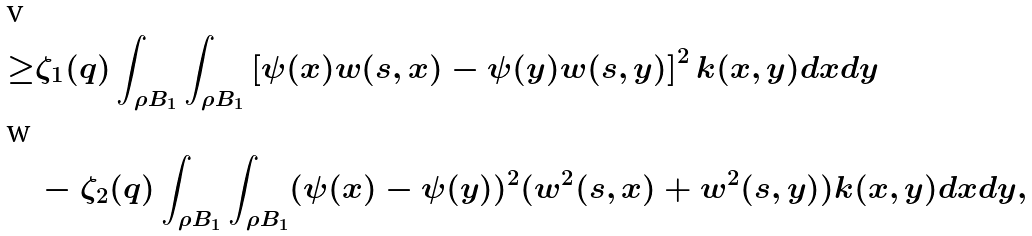<formula> <loc_0><loc_0><loc_500><loc_500>\geq & \zeta _ { 1 } ( q ) \int _ { \rho B _ { 1 } } \int _ { \rho B _ { 1 } } \left [ \psi ( x ) w ( s , x ) - \psi ( y ) w ( s , y ) \right ] ^ { 2 } k ( x , y ) d x d y \\ & - \zeta _ { 2 } ( q ) \int _ { \rho B _ { 1 } } \int _ { \rho B _ { 1 } } ( \psi ( x ) - \psi ( y ) ) ^ { 2 } ( w ^ { 2 } ( s , x ) + w ^ { 2 } ( s , y ) ) k ( x , y ) d x d y ,</formula> 